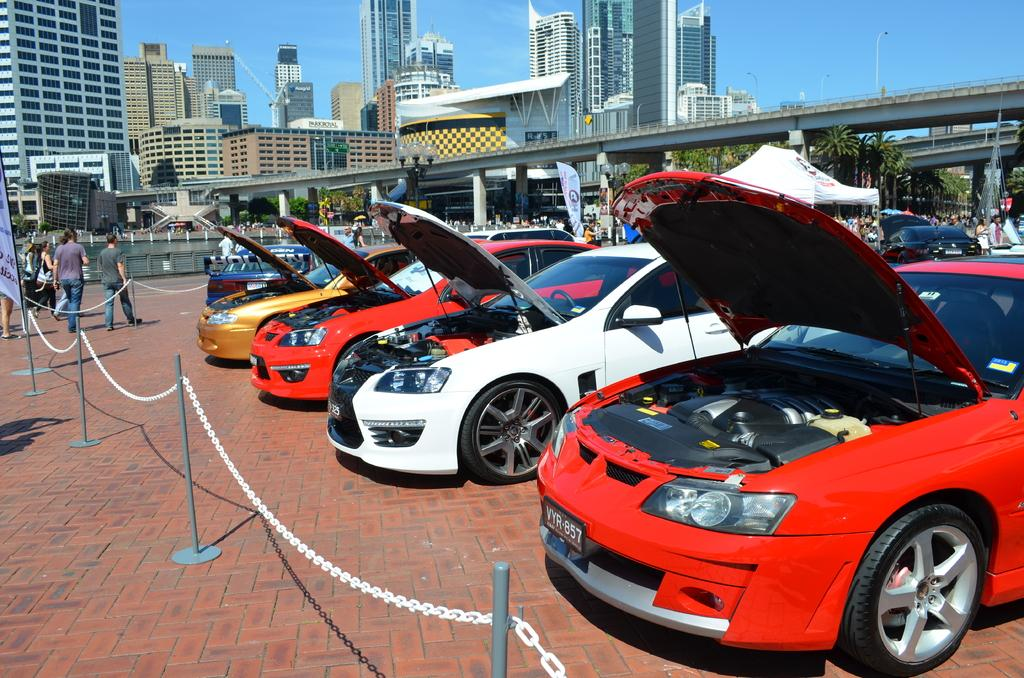What type of vehicles can be seen in the image? There are cars in the image. What else is present in the image besides the cars? There are chains with stands, people walking, a tent, people in the background, a bridge, buildings, lights on poles, and the sky visible in the background. Can you describe the chains with stands in the image? The chains with stands are likely used for holding or securing something, but their specific purpose is not clear from the image. What is the setting of the image? The image appears to be set in an outdoor area with a bridge, buildings, and a tent in the background. What type of cream can be seen smeared on the acoustics in the image? There is no cream or acoustics present in the image. 